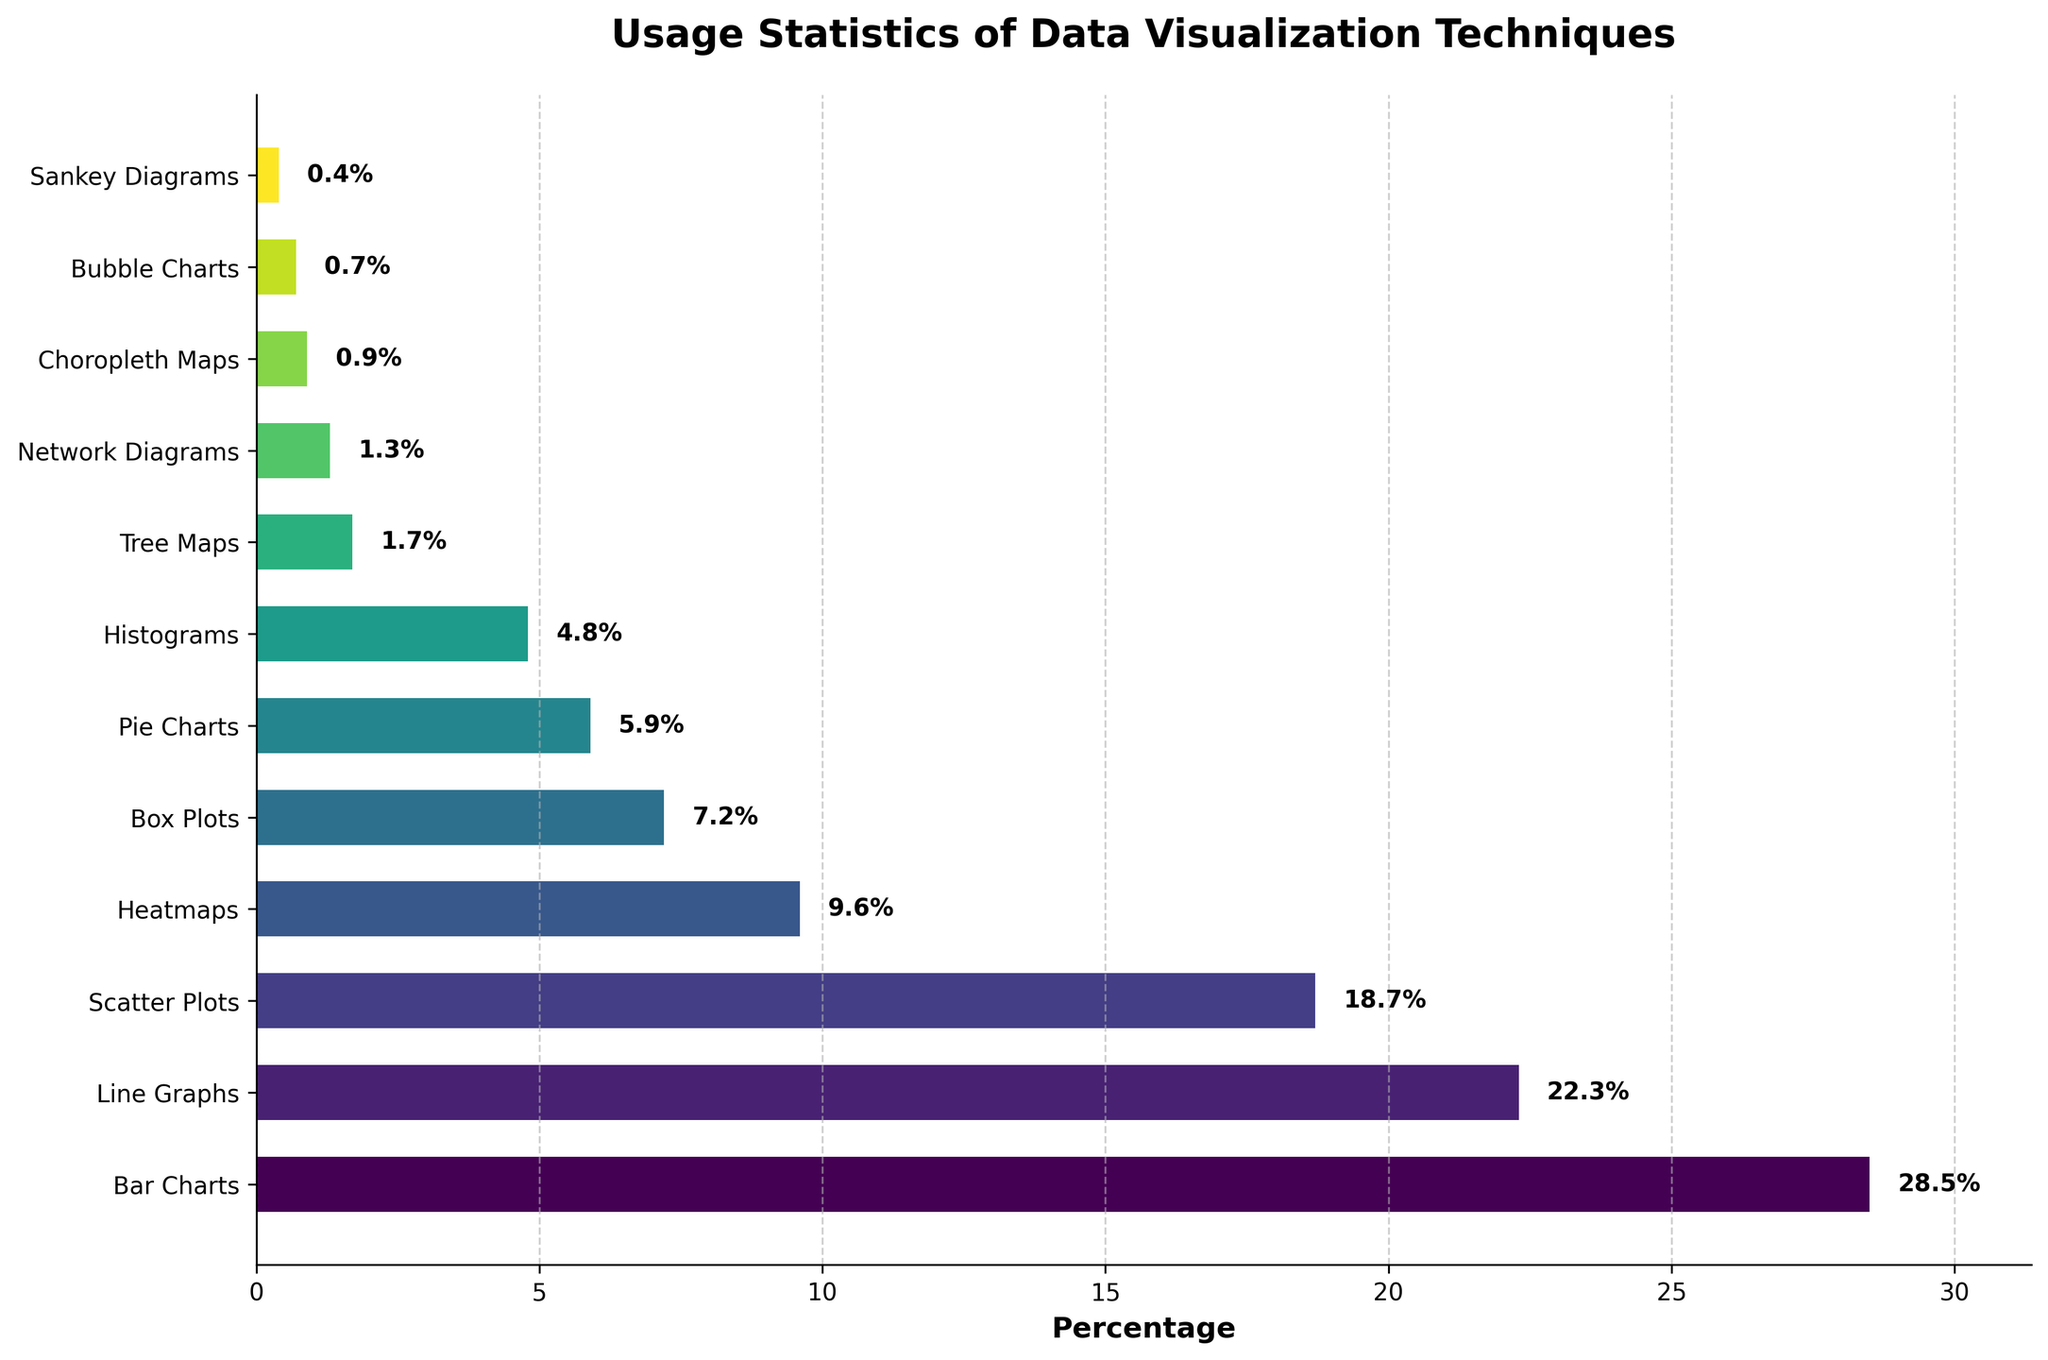What percentage of publications use line graphs? Identify "Line Graphs" in the bar chart and read the corresponding percentage value to determine how commonly it's used compared to other techniques.
Answer: 22.3% Which data visualization technique has the least usage percentage? Identify the smallest bar in the chart, then read the corresponding technique label to find which technique is used the least in publications.
Answer: Sankey Diagrams How much more frequently are bar charts used compared to pie charts? Find the percentage value for both "Bar Charts" and "Pie Charts". Subtract the percentage of "Pie Charts" from the percentage of "Bar Charts" to get the difference. Calculation: 28.5% - 5.9% = 22.6% more.
Answer: 22.6% What is the combined usage percentage of scatter plots and heatmaps? Find the percentage values for both "Scatter Plots" and "Heatmaps". Add these values together to get the combined usage percentage. Calculation: 18.7% + 9.6% = 28.3%.
Answer: 28.3% Which technique is used more frequently, histograms or box plots, and by how much? Compare the percentage values of "Histograms" and "Box Plots". Then, subtract the smaller percentage from the larger one to find the difference. Calculation: 7.2% (Box Plots) - 4.8% (Histograms) = 2.4% more for Box Plots.
Answer: Box Plots by 2.4% How many techniques are used in less than 5% of the publications? Count the bars that represent techniques with percentages less than 5%. These techniques are "Histograms", "Tree Maps", "Network Diagrams", "Choropleth Maps", "Bubble Charts", "Sankey Diagrams". Total count is 6.
Answer: 6 What visual attribute indicates the most popular data visualization technique? Look for the longest bar in the horizontal bar chart. The longest bar visually represents the technique with the highest usage percentage.
Answer: The longest bar Is the usage percentage of network diagrams higher or lower than the usage percentage of heatmaps? Compare the bars representing "Network Diagrams" and "Heatmaps". Read the percentage values and determine which is higher.
Answer: Lower What is the average usage percentage of bar charts, line graphs, and scatter plots? Find the individual percentages of "Bar Charts", "Line Graphs", and "Scatter Plots". Add these values together and divide by 3 to get the average. Calculation: (28.5% + 22.3% + 18.7%) / 3 = 23.16%.
Answer: 23.16% Which techniques have a usage percentage between 1% and 5%? Identify the bars whose percentage values fall between 1% and 5%. These are "Histograms", "Tree Maps", "Network Diagrams", and "Choropleth Maps".
Answer: Histograms, Tree Maps, Network Diagrams, Choropleth Maps 